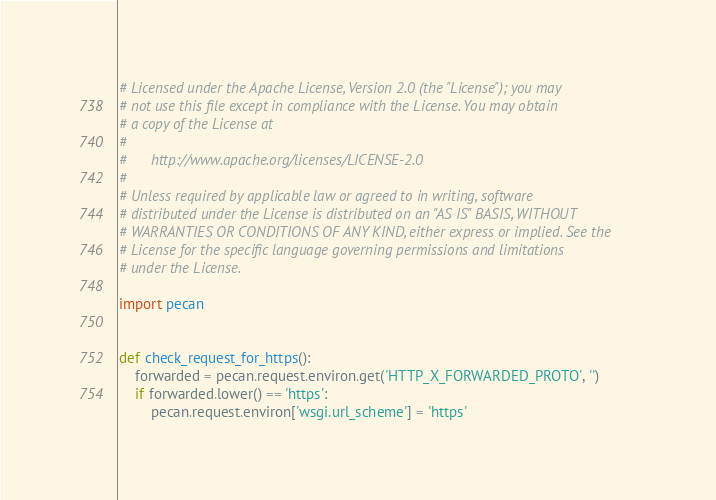<code> <loc_0><loc_0><loc_500><loc_500><_Python_># Licensed under the Apache License, Version 2.0 (the "License"); you may
# not use this file except in compliance with the License. You may obtain
# a copy of the License at
#
#      http://www.apache.org/licenses/LICENSE-2.0
#
# Unless required by applicable law or agreed to in writing, software
# distributed under the License is distributed on an "AS IS" BASIS, WITHOUT
# WARRANTIES OR CONDITIONS OF ANY KIND, either express or implied. See the
# License for the specific language governing permissions and limitations
# under the License.

import pecan


def check_request_for_https():
    forwarded = pecan.request.environ.get('HTTP_X_FORWARDED_PROTO', '')
    if forwarded.lower() == 'https':
        pecan.request.environ['wsgi.url_scheme'] = 'https'
</code> 